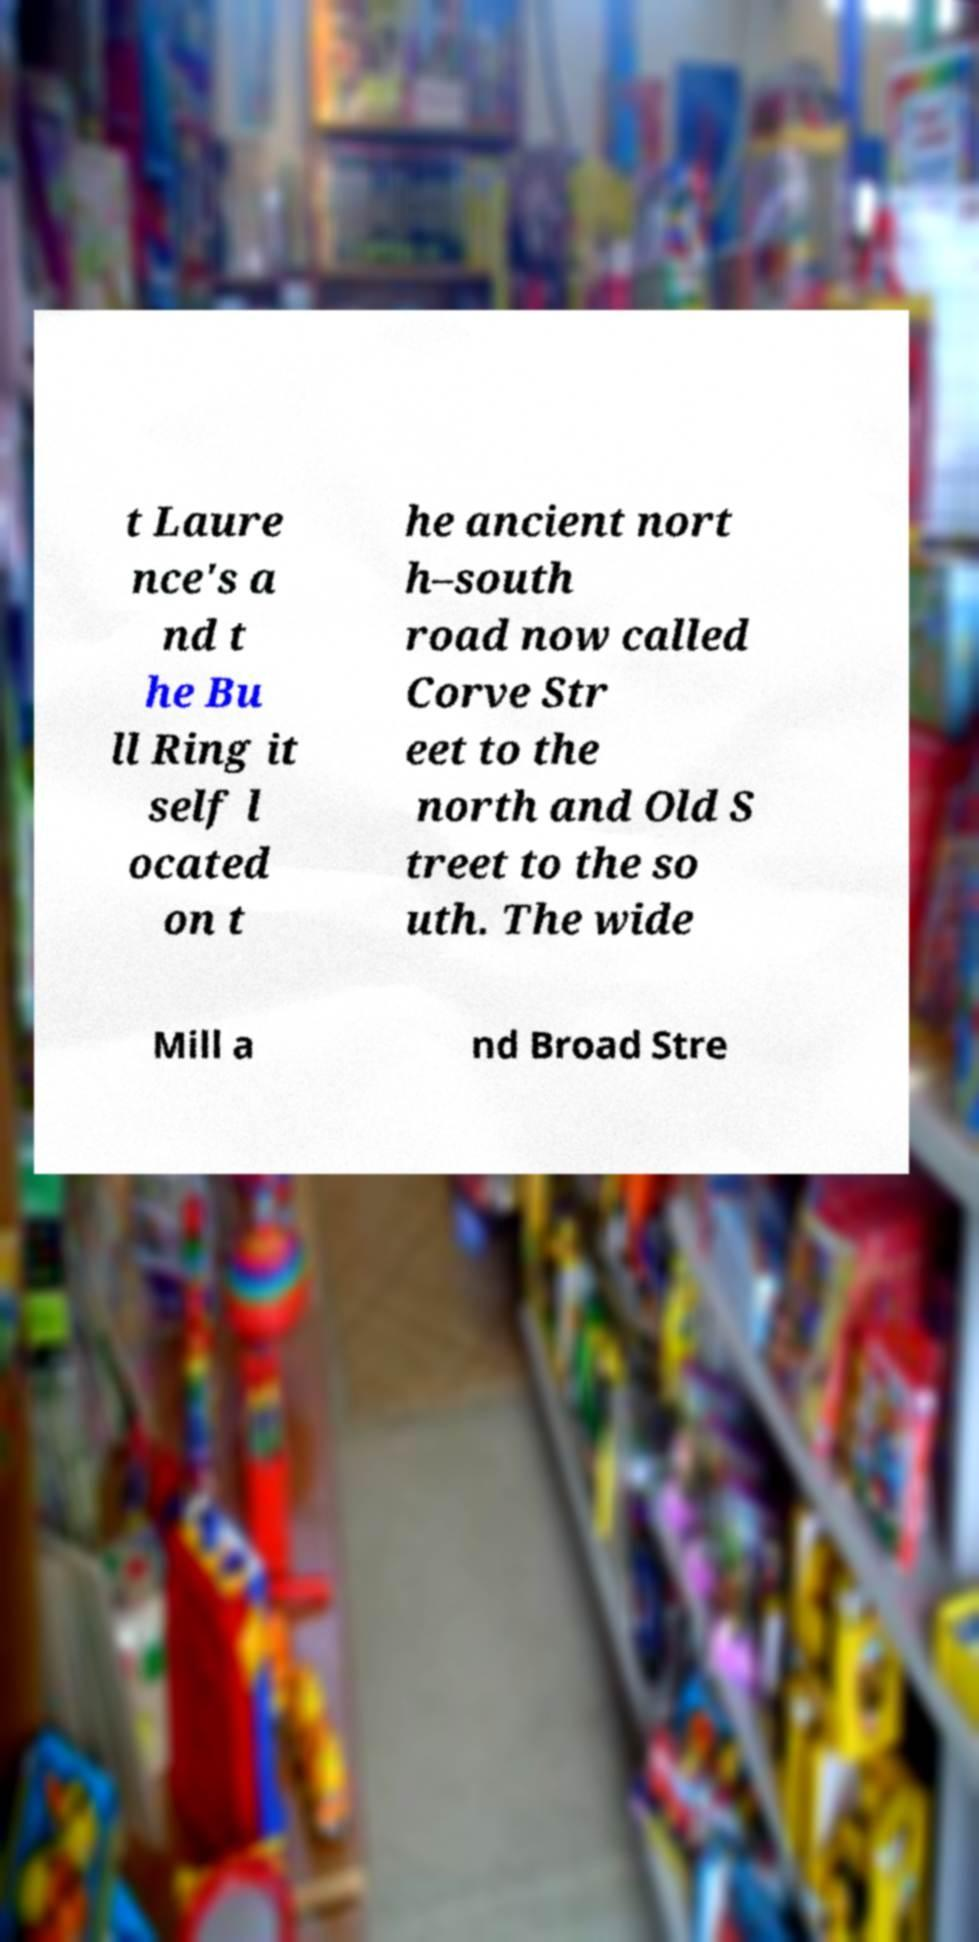I need the written content from this picture converted into text. Can you do that? t Laure nce's a nd t he Bu ll Ring it self l ocated on t he ancient nort h–south road now called Corve Str eet to the north and Old S treet to the so uth. The wide Mill a nd Broad Stre 